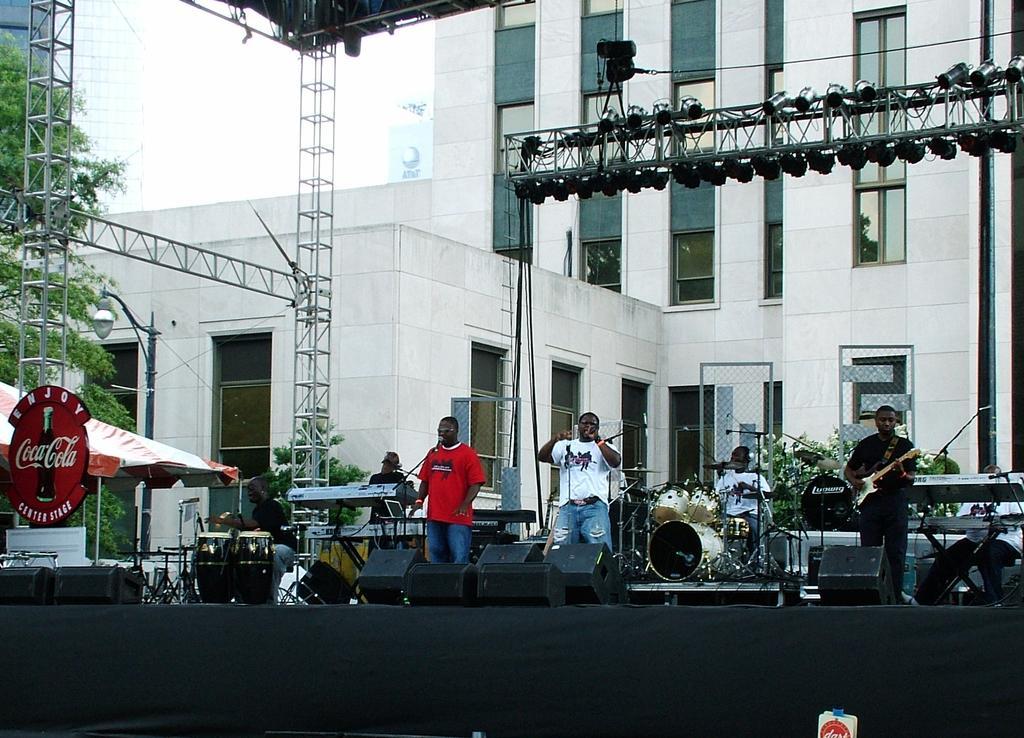In one or two sentences, can you explain what this image depicts? Here in this picture we can see two men are singing. The man with the black dress is playing a guitar. The man with the white t-shirt is playing the drums. And to the right corner there is a man playing piano. Behind them there is a building with the windows. On the top of the stage a there are lighting. On the stage there are some speakers. To the left corner there is a tent. And to the left corner there are trees. 